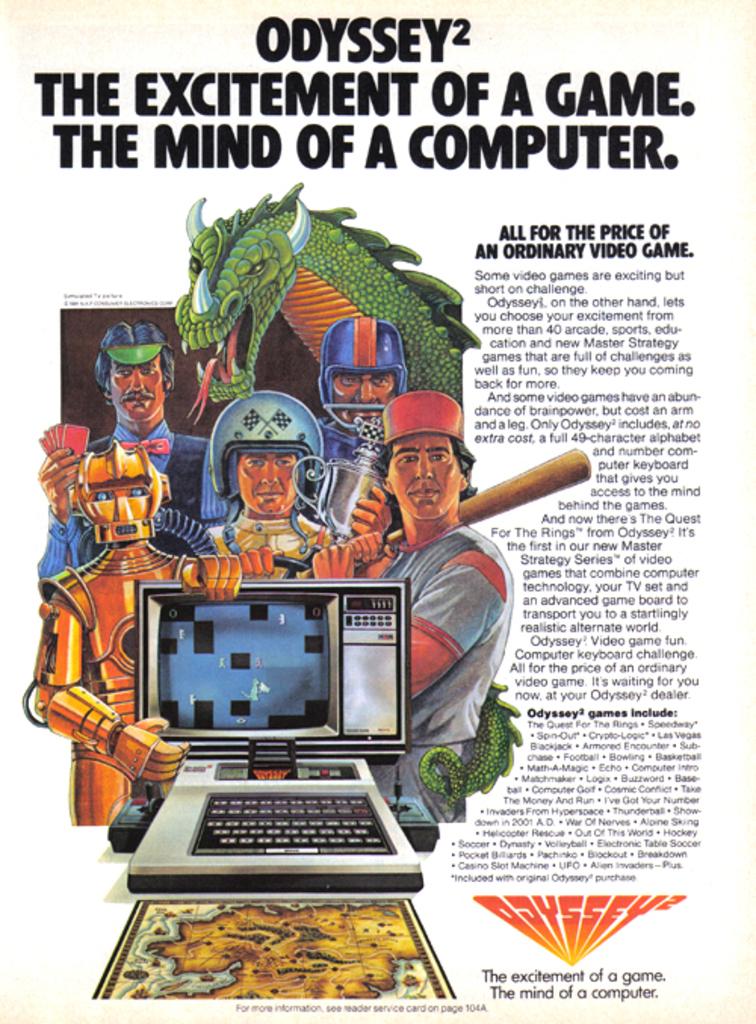So is odyssey a game or a computer?
Offer a terse response. Game. How many games does odyssey contain?
Ensure brevity in your answer.  40. 